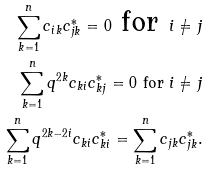Convert formula to latex. <formula><loc_0><loc_0><loc_500><loc_500>\sum _ { k = 1 } ^ { n } c _ { i k } c _ { j k } ^ { * } = 0 \text { for } i \neq j \\ \sum _ { k = 1 } ^ { n } q ^ { 2 k } c _ { k i } c _ { k j } ^ { * } = 0 \text { for } i \neq j \\ \sum _ { k = 1 } ^ { n } q ^ { 2 k - 2 i } c _ { k i } c _ { k i } ^ { * } = \sum _ { k = 1 } ^ { n } c _ { j k } c _ { j k } ^ { * } .</formula> 